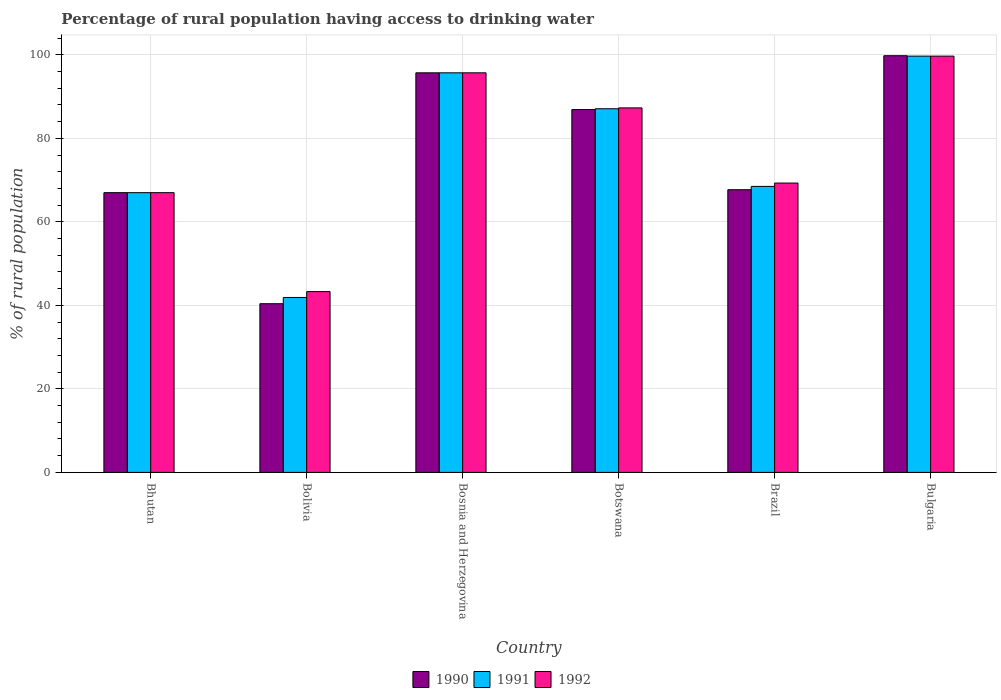How many different coloured bars are there?
Give a very brief answer. 3. How many groups of bars are there?
Offer a very short reply. 6. Are the number of bars per tick equal to the number of legend labels?
Your answer should be compact. Yes. Are the number of bars on each tick of the X-axis equal?
Your answer should be very brief. Yes. What is the label of the 3rd group of bars from the left?
Offer a very short reply. Bosnia and Herzegovina. In how many cases, is the number of bars for a given country not equal to the number of legend labels?
Offer a very short reply. 0. What is the percentage of rural population having access to drinking water in 1990 in Bolivia?
Provide a succinct answer. 40.4. Across all countries, what is the maximum percentage of rural population having access to drinking water in 1991?
Give a very brief answer. 99.7. Across all countries, what is the minimum percentage of rural population having access to drinking water in 1992?
Your response must be concise. 43.3. In which country was the percentage of rural population having access to drinking water in 1992 minimum?
Your answer should be very brief. Bolivia. What is the total percentage of rural population having access to drinking water in 1992 in the graph?
Make the answer very short. 462.3. What is the difference between the percentage of rural population having access to drinking water in 1990 in Bolivia and that in Brazil?
Provide a succinct answer. -27.3. What is the difference between the percentage of rural population having access to drinking water in 1992 in Botswana and the percentage of rural population having access to drinking water in 1991 in Bolivia?
Ensure brevity in your answer.  45.4. What is the average percentage of rural population having access to drinking water in 1992 per country?
Your answer should be very brief. 77.05. What is the difference between the percentage of rural population having access to drinking water of/in 1991 and percentage of rural population having access to drinking water of/in 1990 in Botswana?
Offer a terse response. 0.2. In how many countries, is the percentage of rural population having access to drinking water in 1990 greater than 52 %?
Your response must be concise. 5. What is the ratio of the percentage of rural population having access to drinking water in 1992 in Bosnia and Herzegovina to that in Botswana?
Give a very brief answer. 1.1. What is the difference between the highest and the second highest percentage of rural population having access to drinking water in 1990?
Offer a very short reply. 12.9. What is the difference between the highest and the lowest percentage of rural population having access to drinking water in 1991?
Provide a short and direct response. 57.8. Is the sum of the percentage of rural population having access to drinking water in 1991 in Bolivia and Bosnia and Herzegovina greater than the maximum percentage of rural population having access to drinking water in 1990 across all countries?
Your response must be concise. Yes. What does the 2nd bar from the left in Brazil represents?
Keep it short and to the point. 1991. How many bars are there?
Provide a short and direct response. 18. How many countries are there in the graph?
Offer a terse response. 6. What is the difference between two consecutive major ticks on the Y-axis?
Offer a terse response. 20. Does the graph contain grids?
Ensure brevity in your answer.  Yes. Where does the legend appear in the graph?
Your response must be concise. Bottom center. How many legend labels are there?
Give a very brief answer. 3. How are the legend labels stacked?
Make the answer very short. Horizontal. What is the title of the graph?
Make the answer very short. Percentage of rural population having access to drinking water. Does "1972" appear as one of the legend labels in the graph?
Provide a short and direct response. No. What is the label or title of the Y-axis?
Your answer should be compact. % of rural population. What is the % of rural population of 1990 in Bhutan?
Provide a short and direct response. 67. What is the % of rural population of 1991 in Bhutan?
Make the answer very short. 67. What is the % of rural population of 1990 in Bolivia?
Offer a terse response. 40.4. What is the % of rural population of 1991 in Bolivia?
Offer a terse response. 41.9. What is the % of rural population in 1992 in Bolivia?
Give a very brief answer. 43.3. What is the % of rural population of 1990 in Bosnia and Herzegovina?
Make the answer very short. 95.7. What is the % of rural population of 1991 in Bosnia and Herzegovina?
Make the answer very short. 95.7. What is the % of rural population in 1992 in Bosnia and Herzegovina?
Your answer should be compact. 95.7. What is the % of rural population in 1990 in Botswana?
Provide a short and direct response. 86.9. What is the % of rural population in 1991 in Botswana?
Make the answer very short. 87.1. What is the % of rural population in 1992 in Botswana?
Provide a short and direct response. 87.3. What is the % of rural population of 1990 in Brazil?
Ensure brevity in your answer.  67.7. What is the % of rural population of 1991 in Brazil?
Provide a short and direct response. 68.5. What is the % of rural population of 1992 in Brazil?
Offer a very short reply. 69.3. What is the % of rural population of 1990 in Bulgaria?
Your answer should be very brief. 99.8. What is the % of rural population of 1991 in Bulgaria?
Make the answer very short. 99.7. What is the % of rural population of 1992 in Bulgaria?
Give a very brief answer. 99.7. Across all countries, what is the maximum % of rural population in 1990?
Provide a succinct answer. 99.8. Across all countries, what is the maximum % of rural population in 1991?
Your answer should be compact. 99.7. Across all countries, what is the maximum % of rural population in 1992?
Your response must be concise. 99.7. Across all countries, what is the minimum % of rural population of 1990?
Your answer should be compact. 40.4. Across all countries, what is the minimum % of rural population in 1991?
Provide a short and direct response. 41.9. Across all countries, what is the minimum % of rural population in 1992?
Make the answer very short. 43.3. What is the total % of rural population in 1990 in the graph?
Make the answer very short. 457.5. What is the total % of rural population of 1991 in the graph?
Provide a short and direct response. 459.9. What is the total % of rural population in 1992 in the graph?
Your answer should be very brief. 462.3. What is the difference between the % of rural population in 1990 in Bhutan and that in Bolivia?
Your answer should be compact. 26.6. What is the difference between the % of rural population of 1991 in Bhutan and that in Bolivia?
Provide a short and direct response. 25.1. What is the difference between the % of rural population in 1992 in Bhutan and that in Bolivia?
Offer a very short reply. 23.7. What is the difference between the % of rural population in 1990 in Bhutan and that in Bosnia and Herzegovina?
Your answer should be compact. -28.7. What is the difference between the % of rural population in 1991 in Bhutan and that in Bosnia and Herzegovina?
Your answer should be compact. -28.7. What is the difference between the % of rural population of 1992 in Bhutan and that in Bosnia and Herzegovina?
Your answer should be compact. -28.7. What is the difference between the % of rural population in 1990 in Bhutan and that in Botswana?
Provide a succinct answer. -19.9. What is the difference between the % of rural population in 1991 in Bhutan and that in Botswana?
Give a very brief answer. -20.1. What is the difference between the % of rural population in 1992 in Bhutan and that in Botswana?
Offer a very short reply. -20.3. What is the difference between the % of rural population in 1991 in Bhutan and that in Brazil?
Make the answer very short. -1.5. What is the difference between the % of rural population in 1990 in Bhutan and that in Bulgaria?
Offer a very short reply. -32.8. What is the difference between the % of rural population of 1991 in Bhutan and that in Bulgaria?
Offer a terse response. -32.7. What is the difference between the % of rural population of 1992 in Bhutan and that in Bulgaria?
Your answer should be very brief. -32.7. What is the difference between the % of rural population of 1990 in Bolivia and that in Bosnia and Herzegovina?
Ensure brevity in your answer.  -55.3. What is the difference between the % of rural population in 1991 in Bolivia and that in Bosnia and Herzegovina?
Your answer should be compact. -53.8. What is the difference between the % of rural population in 1992 in Bolivia and that in Bosnia and Herzegovina?
Your answer should be compact. -52.4. What is the difference between the % of rural population in 1990 in Bolivia and that in Botswana?
Offer a very short reply. -46.5. What is the difference between the % of rural population in 1991 in Bolivia and that in Botswana?
Your response must be concise. -45.2. What is the difference between the % of rural population of 1992 in Bolivia and that in Botswana?
Give a very brief answer. -44. What is the difference between the % of rural population of 1990 in Bolivia and that in Brazil?
Give a very brief answer. -27.3. What is the difference between the % of rural population of 1991 in Bolivia and that in Brazil?
Provide a succinct answer. -26.6. What is the difference between the % of rural population in 1992 in Bolivia and that in Brazil?
Make the answer very short. -26. What is the difference between the % of rural population in 1990 in Bolivia and that in Bulgaria?
Keep it short and to the point. -59.4. What is the difference between the % of rural population of 1991 in Bolivia and that in Bulgaria?
Give a very brief answer. -57.8. What is the difference between the % of rural population in 1992 in Bolivia and that in Bulgaria?
Offer a terse response. -56.4. What is the difference between the % of rural population of 1990 in Bosnia and Herzegovina and that in Brazil?
Your response must be concise. 28. What is the difference between the % of rural population of 1991 in Bosnia and Herzegovina and that in Brazil?
Your answer should be compact. 27.2. What is the difference between the % of rural population of 1992 in Bosnia and Herzegovina and that in Brazil?
Your response must be concise. 26.4. What is the difference between the % of rural population in 1990 in Bosnia and Herzegovina and that in Bulgaria?
Your answer should be compact. -4.1. What is the difference between the % of rural population of 1991 in Bosnia and Herzegovina and that in Bulgaria?
Ensure brevity in your answer.  -4. What is the difference between the % of rural population in 1991 in Botswana and that in Brazil?
Offer a very short reply. 18.6. What is the difference between the % of rural population of 1992 in Botswana and that in Brazil?
Offer a terse response. 18. What is the difference between the % of rural population of 1991 in Botswana and that in Bulgaria?
Provide a succinct answer. -12.6. What is the difference between the % of rural population of 1992 in Botswana and that in Bulgaria?
Offer a very short reply. -12.4. What is the difference between the % of rural population in 1990 in Brazil and that in Bulgaria?
Offer a very short reply. -32.1. What is the difference between the % of rural population in 1991 in Brazil and that in Bulgaria?
Offer a terse response. -31.2. What is the difference between the % of rural population in 1992 in Brazil and that in Bulgaria?
Provide a succinct answer. -30.4. What is the difference between the % of rural population of 1990 in Bhutan and the % of rural population of 1991 in Bolivia?
Give a very brief answer. 25.1. What is the difference between the % of rural population in 1990 in Bhutan and the % of rural population in 1992 in Bolivia?
Keep it short and to the point. 23.7. What is the difference between the % of rural population in 1991 in Bhutan and the % of rural population in 1992 in Bolivia?
Your answer should be very brief. 23.7. What is the difference between the % of rural population of 1990 in Bhutan and the % of rural population of 1991 in Bosnia and Herzegovina?
Keep it short and to the point. -28.7. What is the difference between the % of rural population of 1990 in Bhutan and the % of rural population of 1992 in Bosnia and Herzegovina?
Your response must be concise. -28.7. What is the difference between the % of rural population of 1991 in Bhutan and the % of rural population of 1992 in Bosnia and Herzegovina?
Your response must be concise. -28.7. What is the difference between the % of rural population in 1990 in Bhutan and the % of rural population in 1991 in Botswana?
Provide a short and direct response. -20.1. What is the difference between the % of rural population in 1990 in Bhutan and the % of rural population in 1992 in Botswana?
Make the answer very short. -20.3. What is the difference between the % of rural population of 1991 in Bhutan and the % of rural population of 1992 in Botswana?
Offer a terse response. -20.3. What is the difference between the % of rural population of 1990 in Bhutan and the % of rural population of 1991 in Bulgaria?
Your answer should be very brief. -32.7. What is the difference between the % of rural population of 1990 in Bhutan and the % of rural population of 1992 in Bulgaria?
Your answer should be compact. -32.7. What is the difference between the % of rural population in 1991 in Bhutan and the % of rural population in 1992 in Bulgaria?
Your answer should be very brief. -32.7. What is the difference between the % of rural population in 1990 in Bolivia and the % of rural population in 1991 in Bosnia and Herzegovina?
Ensure brevity in your answer.  -55.3. What is the difference between the % of rural population of 1990 in Bolivia and the % of rural population of 1992 in Bosnia and Herzegovina?
Your answer should be very brief. -55.3. What is the difference between the % of rural population in 1991 in Bolivia and the % of rural population in 1992 in Bosnia and Herzegovina?
Your answer should be compact. -53.8. What is the difference between the % of rural population in 1990 in Bolivia and the % of rural population in 1991 in Botswana?
Provide a short and direct response. -46.7. What is the difference between the % of rural population in 1990 in Bolivia and the % of rural population in 1992 in Botswana?
Keep it short and to the point. -46.9. What is the difference between the % of rural population of 1991 in Bolivia and the % of rural population of 1992 in Botswana?
Your response must be concise. -45.4. What is the difference between the % of rural population of 1990 in Bolivia and the % of rural population of 1991 in Brazil?
Offer a very short reply. -28.1. What is the difference between the % of rural population in 1990 in Bolivia and the % of rural population in 1992 in Brazil?
Give a very brief answer. -28.9. What is the difference between the % of rural population of 1991 in Bolivia and the % of rural population of 1992 in Brazil?
Make the answer very short. -27.4. What is the difference between the % of rural population of 1990 in Bolivia and the % of rural population of 1991 in Bulgaria?
Your answer should be very brief. -59.3. What is the difference between the % of rural population in 1990 in Bolivia and the % of rural population in 1992 in Bulgaria?
Make the answer very short. -59.3. What is the difference between the % of rural population of 1991 in Bolivia and the % of rural population of 1992 in Bulgaria?
Provide a short and direct response. -57.8. What is the difference between the % of rural population of 1990 in Bosnia and Herzegovina and the % of rural population of 1991 in Botswana?
Your response must be concise. 8.6. What is the difference between the % of rural population of 1991 in Bosnia and Herzegovina and the % of rural population of 1992 in Botswana?
Ensure brevity in your answer.  8.4. What is the difference between the % of rural population in 1990 in Bosnia and Herzegovina and the % of rural population in 1991 in Brazil?
Provide a succinct answer. 27.2. What is the difference between the % of rural population in 1990 in Bosnia and Herzegovina and the % of rural population in 1992 in Brazil?
Give a very brief answer. 26.4. What is the difference between the % of rural population of 1991 in Bosnia and Herzegovina and the % of rural population of 1992 in Brazil?
Your response must be concise. 26.4. What is the difference between the % of rural population in 1990 in Bosnia and Herzegovina and the % of rural population in 1991 in Bulgaria?
Provide a succinct answer. -4. What is the difference between the % of rural population of 1990 in Bosnia and Herzegovina and the % of rural population of 1992 in Bulgaria?
Make the answer very short. -4. What is the difference between the % of rural population in 1990 in Botswana and the % of rural population in 1991 in Brazil?
Make the answer very short. 18.4. What is the difference between the % of rural population in 1991 in Botswana and the % of rural population in 1992 in Brazil?
Give a very brief answer. 17.8. What is the difference between the % of rural population of 1990 in Botswana and the % of rural population of 1991 in Bulgaria?
Offer a terse response. -12.8. What is the difference between the % of rural population in 1990 in Botswana and the % of rural population in 1992 in Bulgaria?
Provide a succinct answer. -12.8. What is the difference between the % of rural population of 1991 in Botswana and the % of rural population of 1992 in Bulgaria?
Provide a short and direct response. -12.6. What is the difference between the % of rural population in 1990 in Brazil and the % of rural population in 1991 in Bulgaria?
Keep it short and to the point. -32. What is the difference between the % of rural population in 1990 in Brazil and the % of rural population in 1992 in Bulgaria?
Make the answer very short. -32. What is the difference between the % of rural population in 1991 in Brazil and the % of rural population in 1992 in Bulgaria?
Offer a very short reply. -31.2. What is the average % of rural population in 1990 per country?
Give a very brief answer. 76.25. What is the average % of rural population of 1991 per country?
Make the answer very short. 76.65. What is the average % of rural population of 1992 per country?
Provide a succinct answer. 77.05. What is the difference between the % of rural population of 1990 and % of rural population of 1991 in Bhutan?
Keep it short and to the point. 0. What is the difference between the % of rural population of 1990 and % of rural population of 1991 in Bosnia and Herzegovina?
Provide a short and direct response. 0. What is the difference between the % of rural population of 1990 and % of rural population of 1992 in Bosnia and Herzegovina?
Provide a short and direct response. 0. What is the difference between the % of rural population of 1990 and % of rural population of 1991 in Botswana?
Offer a very short reply. -0.2. What is the difference between the % of rural population in 1990 and % of rural population in 1992 in Botswana?
Your answer should be very brief. -0.4. What is the difference between the % of rural population of 1990 and % of rural population of 1991 in Brazil?
Your answer should be compact. -0.8. What is the difference between the % of rural population of 1991 and % of rural population of 1992 in Brazil?
Provide a succinct answer. -0.8. What is the difference between the % of rural population in 1990 and % of rural population in 1991 in Bulgaria?
Provide a succinct answer. 0.1. What is the difference between the % of rural population of 1991 and % of rural population of 1992 in Bulgaria?
Your response must be concise. 0. What is the ratio of the % of rural population in 1990 in Bhutan to that in Bolivia?
Your response must be concise. 1.66. What is the ratio of the % of rural population in 1991 in Bhutan to that in Bolivia?
Your response must be concise. 1.6. What is the ratio of the % of rural population of 1992 in Bhutan to that in Bolivia?
Your answer should be compact. 1.55. What is the ratio of the % of rural population in 1990 in Bhutan to that in Bosnia and Herzegovina?
Your response must be concise. 0.7. What is the ratio of the % of rural population in 1991 in Bhutan to that in Bosnia and Herzegovina?
Offer a very short reply. 0.7. What is the ratio of the % of rural population in 1992 in Bhutan to that in Bosnia and Herzegovina?
Your answer should be compact. 0.7. What is the ratio of the % of rural population of 1990 in Bhutan to that in Botswana?
Keep it short and to the point. 0.77. What is the ratio of the % of rural population in 1991 in Bhutan to that in Botswana?
Your answer should be very brief. 0.77. What is the ratio of the % of rural population of 1992 in Bhutan to that in Botswana?
Make the answer very short. 0.77. What is the ratio of the % of rural population of 1990 in Bhutan to that in Brazil?
Provide a succinct answer. 0.99. What is the ratio of the % of rural population of 1991 in Bhutan to that in Brazil?
Your answer should be compact. 0.98. What is the ratio of the % of rural population in 1992 in Bhutan to that in Brazil?
Give a very brief answer. 0.97. What is the ratio of the % of rural population in 1990 in Bhutan to that in Bulgaria?
Your response must be concise. 0.67. What is the ratio of the % of rural population in 1991 in Bhutan to that in Bulgaria?
Make the answer very short. 0.67. What is the ratio of the % of rural population of 1992 in Bhutan to that in Bulgaria?
Offer a very short reply. 0.67. What is the ratio of the % of rural population in 1990 in Bolivia to that in Bosnia and Herzegovina?
Keep it short and to the point. 0.42. What is the ratio of the % of rural population of 1991 in Bolivia to that in Bosnia and Herzegovina?
Your answer should be very brief. 0.44. What is the ratio of the % of rural population in 1992 in Bolivia to that in Bosnia and Herzegovina?
Your answer should be very brief. 0.45. What is the ratio of the % of rural population in 1990 in Bolivia to that in Botswana?
Your response must be concise. 0.46. What is the ratio of the % of rural population in 1991 in Bolivia to that in Botswana?
Ensure brevity in your answer.  0.48. What is the ratio of the % of rural population in 1992 in Bolivia to that in Botswana?
Ensure brevity in your answer.  0.5. What is the ratio of the % of rural population of 1990 in Bolivia to that in Brazil?
Your answer should be very brief. 0.6. What is the ratio of the % of rural population in 1991 in Bolivia to that in Brazil?
Keep it short and to the point. 0.61. What is the ratio of the % of rural population of 1992 in Bolivia to that in Brazil?
Offer a very short reply. 0.62. What is the ratio of the % of rural population of 1990 in Bolivia to that in Bulgaria?
Ensure brevity in your answer.  0.4. What is the ratio of the % of rural population of 1991 in Bolivia to that in Bulgaria?
Provide a short and direct response. 0.42. What is the ratio of the % of rural population of 1992 in Bolivia to that in Bulgaria?
Give a very brief answer. 0.43. What is the ratio of the % of rural population of 1990 in Bosnia and Herzegovina to that in Botswana?
Your answer should be very brief. 1.1. What is the ratio of the % of rural population in 1991 in Bosnia and Herzegovina to that in Botswana?
Provide a succinct answer. 1.1. What is the ratio of the % of rural population of 1992 in Bosnia and Herzegovina to that in Botswana?
Your answer should be compact. 1.1. What is the ratio of the % of rural population in 1990 in Bosnia and Herzegovina to that in Brazil?
Provide a succinct answer. 1.41. What is the ratio of the % of rural population in 1991 in Bosnia and Herzegovina to that in Brazil?
Offer a terse response. 1.4. What is the ratio of the % of rural population in 1992 in Bosnia and Herzegovina to that in Brazil?
Keep it short and to the point. 1.38. What is the ratio of the % of rural population in 1990 in Bosnia and Herzegovina to that in Bulgaria?
Provide a succinct answer. 0.96. What is the ratio of the % of rural population in 1991 in Bosnia and Herzegovina to that in Bulgaria?
Keep it short and to the point. 0.96. What is the ratio of the % of rural population of 1992 in Bosnia and Herzegovina to that in Bulgaria?
Your answer should be very brief. 0.96. What is the ratio of the % of rural population of 1990 in Botswana to that in Brazil?
Your answer should be very brief. 1.28. What is the ratio of the % of rural population in 1991 in Botswana to that in Brazil?
Give a very brief answer. 1.27. What is the ratio of the % of rural population of 1992 in Botswana to that in Brazil?
Provide a short and direct response. 1.26. What is the ratio of the % of rural population in 1990 in Botswana to that in Bulgaria?
Make the answer very short. 0.87. What is the ratio of the % of rural population in 1991 in Botswana to that in Bulgaria?
Offer a terse response. 0.87. What is the ratio of the % of rural population in 1992 in Botswana to that in Bulgaria?
Your response must be concise. 0.88. What is the ratio of the % of rural population in 1990 in Brazil to that in Bulgaria?
Your response must be concise. 0.68. What is the ratio of the % of rural population of 1991 in Brazil to that in Bulgaria?
Provide a succinct answer. 0.69. What is the ratio of the % of rural population in 1992 in Brazil to that in Bulgaria?
Your response must be concise. 0.7. What is the difference between the highest and the second highest % of rural population in 1990?
Your answer should be compact. 4.1. What is the difference between the highest and the second highest % of rural population of 1991?
Give a very brief answer. 4. What is the difference between the highest and the second highest % of rural population in 1992?
Offer a terse response. 4. What is the difference between the highest and the lowest % of rural population in 1990?
Your response must be concise. 59.4. What is the difference between the highest and the lowest % of rural population in 1991?
Your answer should be very brief. 57.8. What is the difference between the highest and the lowest % of rural population in 1992?
Keep it short and to the point. 56.4. 